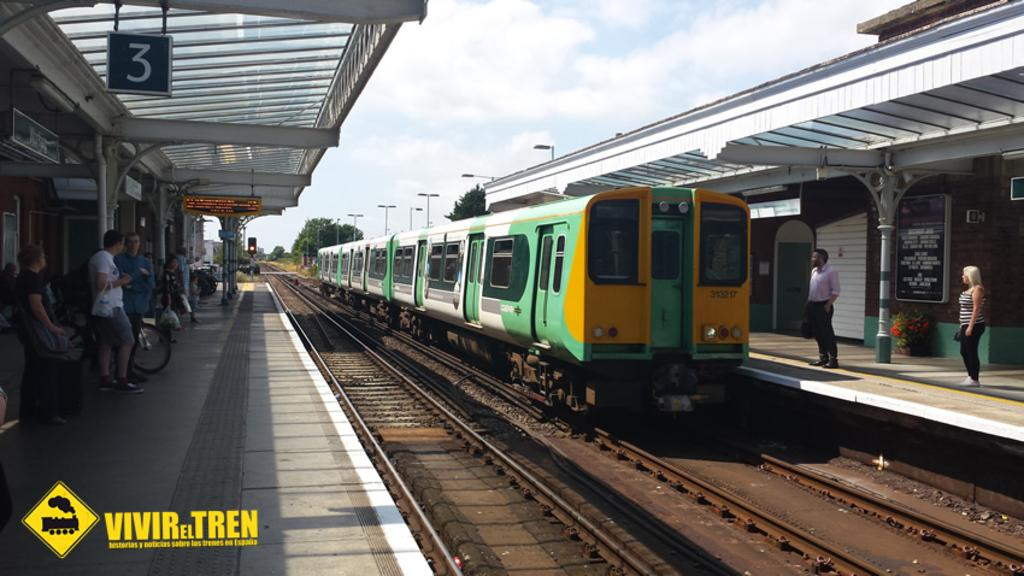<image>
Create a compact narrative representing the image presented. Platform number three is shown on a sign next to the approaching train. 